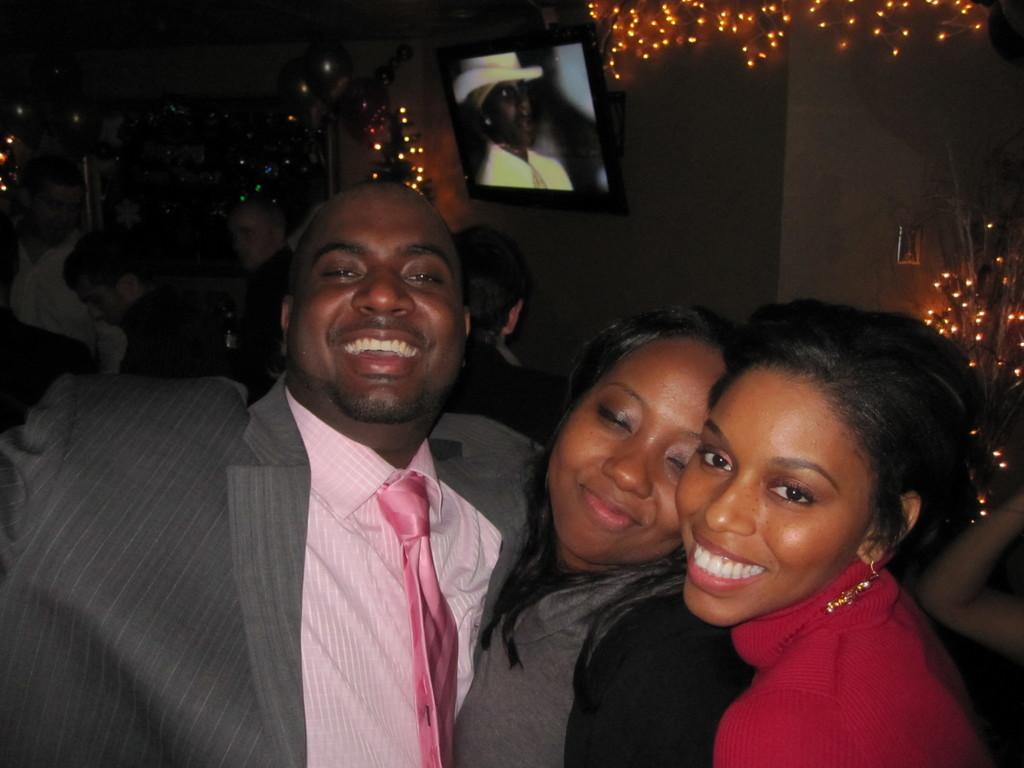Can you describe this image briefly? In this image there is a man and two women posing for the camera with a smile on their face, behind them there are a few other people, in the background of the image there is a wall mounted television on the wall, and the wall is decorated with lights. 